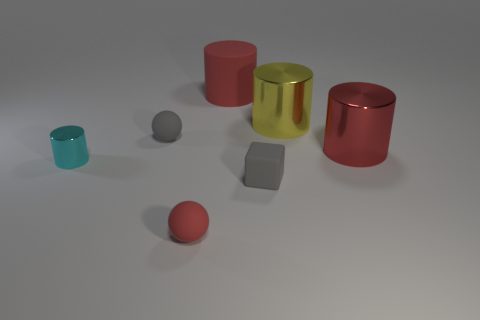Do the large yellow cylinder and the cube have the same material?
Provide a succinct answer. No. There is a tiny matte thing that is in front of the small gray rubber object in front of the tiny cyan cylinder; how many small blocks are behind it?
Give a very brief answer. 1. The large cylinder that is on the right side of the yellow cylinder is what color?
Your answer should be compact. Red. What is the shape of the big red object that is to the right of the tiny rubber cube that is in front of the small cyan cylinder?
Your answer should be very brief. Cylinder. Is the small rubber cube the same color as the small shiny object?
Your answer should be compact. No. What number of cubes are either yellow shiny things or red matte things?
Your answer should be very brief. 0. The cylinder that is on the left side of the large yellow thing and behind the cyan shiny object is made of what material?
Make the answer very short. Rubber. There is a small rubber cube; what number of cyan cylinders are behind it?
Give a very brief answer. 1. Is the material of the small gray thing that is to the left of the small gray block the same as the large red thing in front of the large red rubber cylinder?
Your answer should be very brief. No. What number of things are red things in front of the large red rubber thing or tiny gray matte blocks?
Keep it short and to the point. 3. 